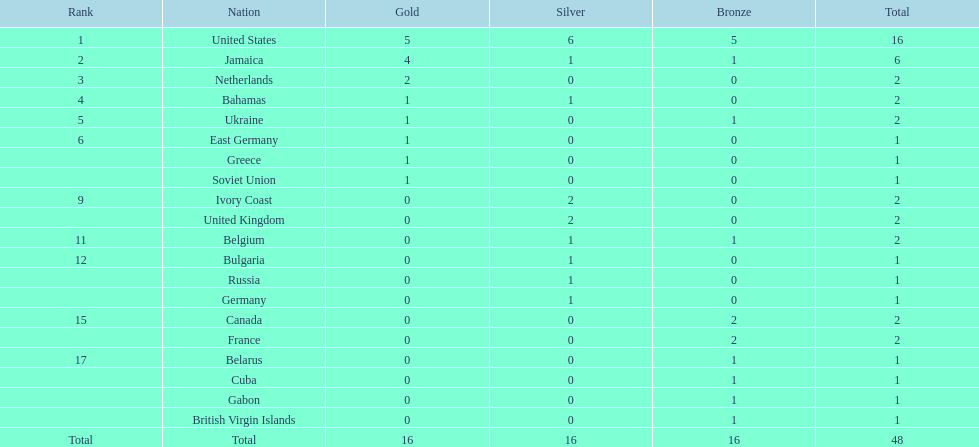How many nations won no gold medals? 12. 